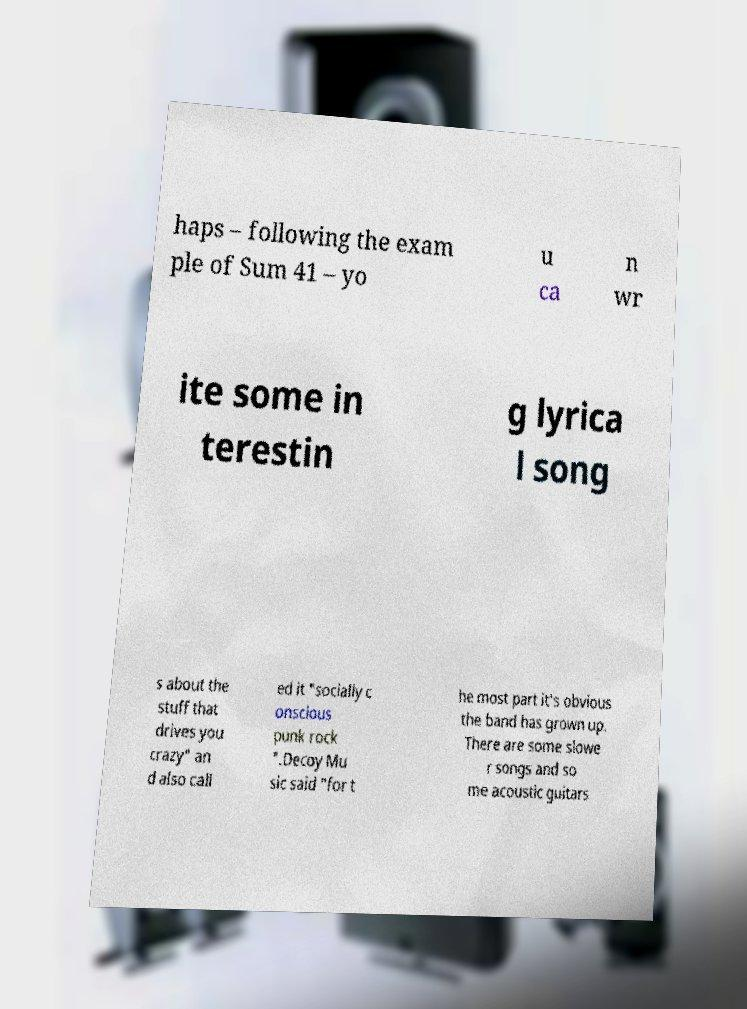I need the written content from this picture converted into text. Can you do that? haps – following the exam ple of Sum 41 – yo u ca n wr ite some in terestin g lyrica l song s about the stuff that drives you crazy" an d also call ed it "socially c onscious punk rock ".Decoy Mu sic said "for t he most part it's obvious the band has grown up. There are some slowe r songs and so me acoustic guitars 